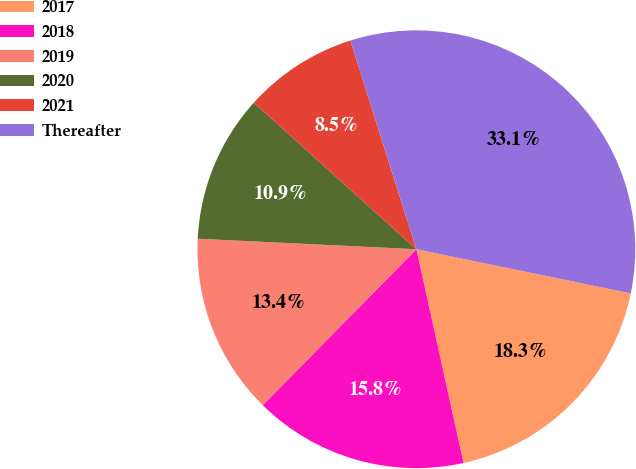<chart> <loc_0><loc_0><loc_500><loc_500><pie_chart><fcel>2017<fcel>2018<fcel>2019<fcel>2020<fcel>2021<fcel>Thereafter<nl><fcel>18.31%<fcel>15.84%<fcel>13.38%<fcel>10.91%<fcel>8.45%<fcel>33.1%<nl></chart> 